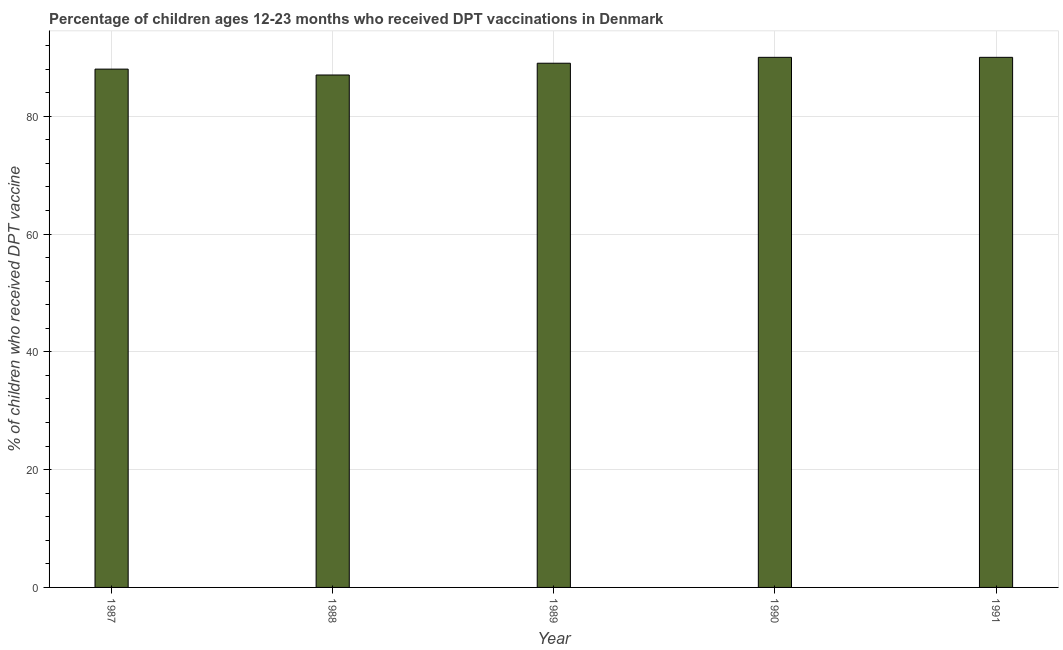What is the title of the graph?
Your response must be concise. Percentage of children ages 12-23 months who received DPT vaccinations in Denmark. What is the label or title of the Y-axis?
Your answer should be compact. % of children who received DPT vaccine. What is the percentage of children who received dpt vaccine in 1989?
Provide a short and direct response. 89. In which year was the percentage of children who received dpt vaccine maximum?
Offer a very short reply. 1990. What is the sum of the percentage of children who received dpt vaccine?
Your response must be concise. 444. What is the median percentage of children who received dpt vaccine?
Your answer should be very brief. 89. Do a majority of the years between 1991 and 1990 (inclusive) have percentage of children who received dpt vaccine greater than 48 %?
Your answer should be compact. No. What is the ratio of the percentage of children who received dpt vaccine in 1988 to that in 1989?
Offer a terse response. 0.98. Is the difference between the percentage of children who received dpt vaccine in 1988 and 1991 greater than the difference between any two years?
Offer a terse response. Yes. What is the difference between the highest and the second highest percentage of children who received dpt vaccine?
Your response must be concise. 0. In how many years, is the percentage of children who received dpt vaccine greater than the average percentage of children who received dpt vaccine taken over all years?
Provide a short and direct response. 3. How many bars are there?
Give a very brief answer. 5. Are all the bars in the graph horizontal?
Keep it short and to the point. No. How many years are there in the graph?
Your answer should be very brief. 5. What is the difference between two consecutive major ticks on the Y-axis?
Offer a very short reply. 20. Are the values on the major ticks of Y-axis written in scientific E-notation?
Keep it short and to the point. No. What is the % of children who received DPT vaccine of 1987?
Ensure brevity in your answer.  88. What is the % of children who received DPT vaccine of 1988?
Your response must be concise. 87. What is the % of children who received DPT vaccine of 1989?
Your answer should be very brief. 89. What is the % of children who received DPT vaccine of 1990?
Provide a short and direct response. 90. What is the difference between the % of children who received DPT vaccine in 1987 and 1988?
Give a very brief answer. 1. What is the difference between the % of children who received DPT vaccine in 1987 and 1991?
Your response must be concise. -2. What is the difference between the % of children who received DPT vaccine in 1988 and 1989?
Your answer should be compact. -2. What is the difference between the % of children who received DPT vaccine in 1988 and 1990?
Provide a short and direct response. -3. What is the difference between the % of children who received DPT vaccine in 1988 and 1991?
Provide a short and direct response. -3. What is the difference between the % of children who received DPT vaccine in 1989 and 1991?
Offer a very short reply. -1. What is the difference between the % of children who received DPT vaccine in 1990 and 1991?
Provide a succinct answer. 0. What is the ratio of the % of children who received DPT vaccine in 1987 to that in 1989?
Your answer should be compact. 0.99. What is the ratio of the % of children who received DPT vaccine in 1987 to that in 1991?
Provide a short and direct response. 0.98. What is the ratio of the % of children who received DPT vaccine in 1988 to that in 1989?
Ensure brevity in your answer.  0.98. What is the ratio of the % of children who received DPT vaccine in 1989 to that in 1991?
Your answer should be compact. 0.99. What is the ratio of the % of children who received DPT vaccine in 1990 to that in 1991?
Provide a short and direct response. 1. 